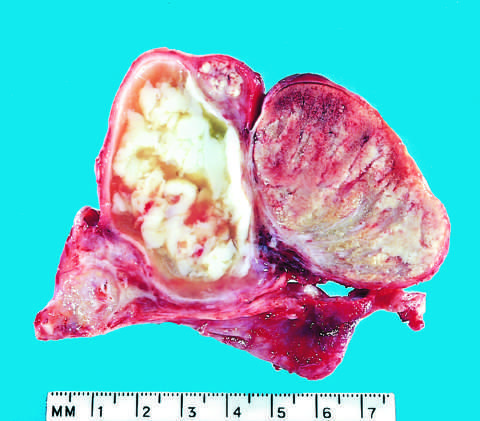s the irreversible injury seen on the right?
Answer the question using a single word or phrase. No 